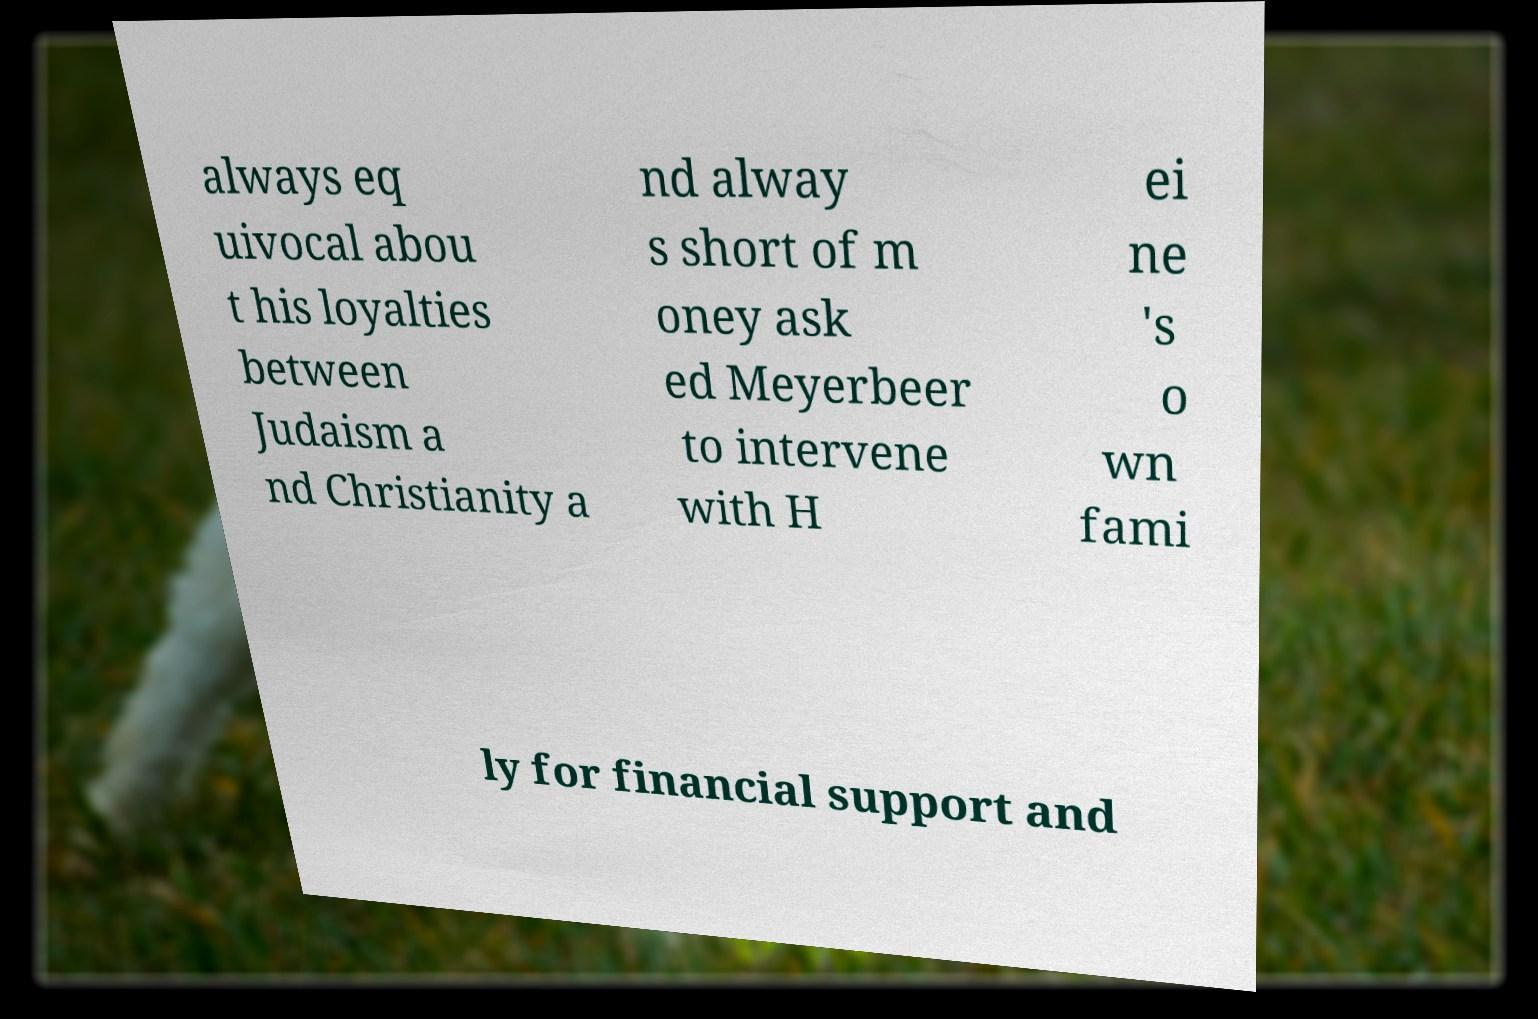For documentation purposes, I need the text within this image transcribed. Could you provide that? always eq uivocal abou t his loyalties between Judaism a nd Christianity a nd alway s short of m oney ask ed Meyerbeer to intervene with H ei ne 's o wn fami ly for financial support and 